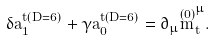Convert formula to latex. <formula><loc_0><loc_0><loc_500><loc_500>\delta a _ { 1 } ^ { t ( D = 6 ) } + \gamma a _ { 0 } ^ { t ( D = 6 ) } = \partial _ { \mu } \overset { ( 0 ) } { m } _ { t } ^ { \mu } .</formula> 